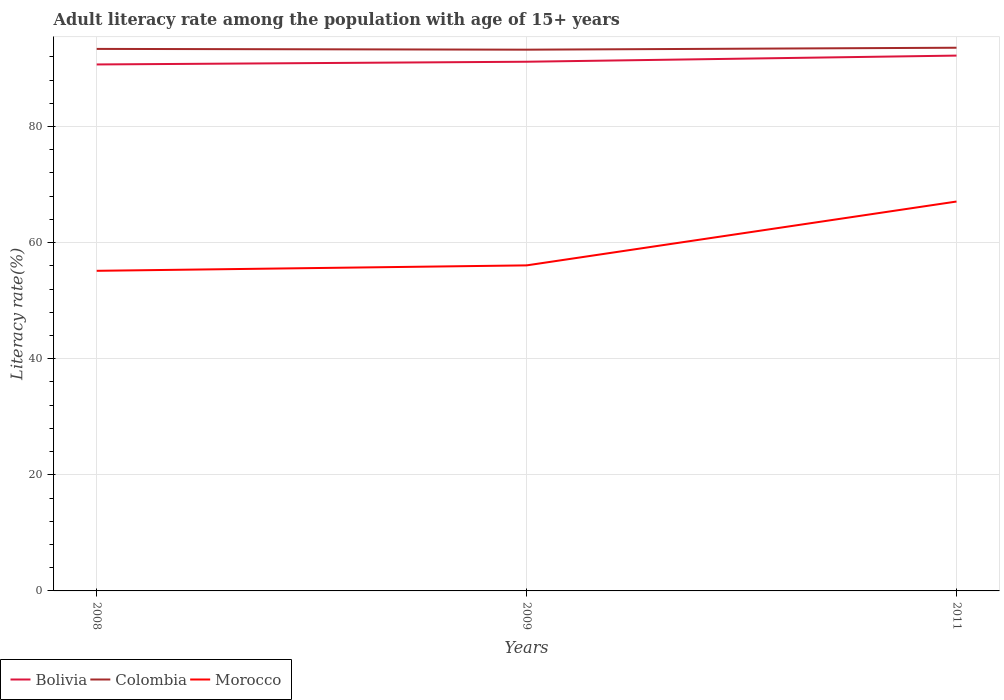Does the line corresponding to Colombia intersect with the line corresponding to Bolivia?
Your answer should be very brief. No. Across all years, what is the maximum adult literacy rate in Colombia?
Your answer should be very brief. 93.24. What is the total adult literacy rate in Colombia in the graph?
Offer a very short reply. -0.2. What is the difference between the highest and the second highest adult literacy rate in Bolivia?
Provide a succinct answer. 1.53. Is the adult literacy rate in Bolivia strictly greater than the adult literacy rate in Morocco over the years?
Your response must be concise. No. How many lines are there?
Provide a succinct answer. 3. How many years are there in the graph?
Keep it short and to the point. 3. Does the graph contain any zero values?
Keep it short and to the point. No. Does the graph contain grids?
Provide a succinct answer. Yes. How many legend labels are there?
Your answer should be very brief. 3. What is the title of the graph?
Provide a short and direct response. Adult literacy rate among the population with age of 15+ years. What is the label or title of the X-axis?
Provide a succinct answer. Years. What is the label or title of the Y-axis?
Ensure brevity in your answer.  Literacy rate(%). What is the Literacy rate(%) of Bolivia in 2008?
Provide a short and direct response. 90.7. What is the Literacy rate(%) of Colombia in 2008?
Make the answer very short. 93.38. What is the Literacy rate(%) in Morocco in 2008?
Offer a terse response. 55.15. What is the Literacy rate(%) of Bolivia in 2009?
Your answer should be very brief. 91.17. What is the Literacy rate(%) of Colombia in 2009?
Offer a terse response. 93.24. What is the Literacy rate(%) of Morocco in 2009?
Offer a terse response. 56.08. What is the Literacy rate(%) in Bolivia in 2011?
Give a very brief answer. 92.23. What is the Literacy rate(%) in Colombia in 2011?
Ensure brevity in your answer.  93.58. What is the Literacy rate(%) of Morocco in 2011?
Your response must be concise. 67.08. Across all years, what is the maximum Literacy rate(%) in Bolivia?
Make the answer very short. 92.23. Across all years, what is the maximum Literacy rate(%) in Colombia?
Provide a short and direct response. 93.58. Across all years, what is the maximum Literacy rate(%) of Morocco?
Make the answer very short. 67.08. Across all years, what is the minimum Literacy rate(%) of Bolivia?
Provide a short and direct response. 90.7. Across all years, what is the minimum Literacy rate(%) of Colombia?
Give a very brief answer. 93.24. Across all years, what is the minimum Literacy rate(%) in Morocco?
Provide a short and direct response. 55.15. What is the total Literacy rate(%) in Bolivia in the graph?
Your answer should be compact. 274.09. What is the total Literacy rate(%) in Colombia in the graph?
Keep it short and to the point. 280.2. What is the total Literacy rate(%) of Morocco in the graph?
Give a very brief answer. 178.32. What is the difference between the Literacy rate(%) of Bolivia in 2008 and that in 2009?
Give a very brief answer. -0.47. What is the difference between the Literacy rate(%) of Colombia in 2008 and that in 2009?
Your response must be concise. 0.13. What is the difference between the Literacy rate(%) of Morocco in 2008 and that in 2009?
Your answer should be compact. -0.94. What is the difference between the Literacy rate(%) in Bolivia in 2008 and that in 2011?
Provide a succinct answer. -1.53. What is the difference between the Literacy rate(%) of Colombia in 2008 and that in 2011?
Give a very brief answer. -0.2. What is the difference between the Literacy rate(%) in Morocco in 2008 and that in 2011?
Provide a short and direct response. -11.94. What is the difference between the Literacy rate(%) of Bolivia in 2009 and that in 2011?
Give a very brief answer. -1.06. What is the difference between the Literacy rate(%) in Colombia in 2009 and that in 2011?
Offer a terse response. -0.34. What is the difference between the Literacy rate(%) of Morocco in 2009 and that in 2011?
Your answer should be compact. -11. What is the difference between the Literacy rate(%) of Bolivia in 2008 and the Literacy rate(%) of Colombia in 2009?
Make the answer very short. -2.55. What is the difference between the Literacy rate(%) in Bolivia in 2008 and the Literacy rate(%) in Morocco in 2009?
Make the answer very short. 34.61. What is the difference between the Literacy rate(%) of Colombia in 2008 and the Literacy rate(%) of Morocco in 2009?
Your answer should be compact. 37.29. What is the difference between the Literacy rate(%) in Bolivia in 2008 and the Literacy rate(%) in Colombia in 2011?
Provide a short and direct response. -2.88. What is the difference between the Literacy rate(%) of Bolivia in 2008 and the Literacy rate(%) of Morocco in 2011?
Give a very brief answer. 23.61. What is the difference between the Literacy rate(%) in Colombia in 2008 and the Literacy rate(%) in Morocco in 2011?
Your response must be concise. 26.29. What is the difference between the Literacy rate(%) in Bolivia in 2009 and the Literacy rate(%) in Colombia in 2011?
Ensure brevity in your answer.  -2.41. What is the difference between the Literacy rate(%) in Bolivia in 2009 and the Literacy rate(%) in Morocco in 2011?
Offer a terse response. 24.08. What is the difference between the Literacy rate(%) of Colombia in 2009 and the Literacy rate(%) of Morocco in 2011?
Offer a very short reply. 26.16. What is the average Literacy rate(%) in Bolivia per year?
Ensure brevity in your answer.  91.36. What is the average Literacy rate(%) of Colombia per year?
Your answer should be very brief. 93.4. What is the average Literacy rate(%) of Morocco per year?
Make the answer very short. 59.44. In the year 2008, what is the difference between the Literacy rate(%) in Bolivia and Literacy rate(%) in Colombia?
Keep it short and to the point. -2.68. In the year 2008, what is the difference between the Literacy rate(%) of Bolivia and Literacy rate(%) of Morocco?
Make the answer very short. 35.55. In the year 2008, what is the difference between the Literacy rate(%) of Colombia and Literacy rate(%) of Morocco?
Make the answer very short. 38.23. In the year 2009, what is the difference between the Literacy rate(%) of Bolivia and Literacy rate(%) of Colombia?
Keep it short and to the point. -2.08. In the year 2009, what is the difference between the Literacy rate(%) in Bolivia and Literacy rate(%) in Morocco?
Offer a terse response. 35.08. In the year 2009, what is the difference between the Literacy rate(%) in Colombia and Literacy rate(%) in Morocco?
Provide a succinct answer. 37.16. In the year 2011, what is the difference between the Literacy rate(%) of Bolivia and Literacy rate(%) of Colombia?
Offer a terse response. -1.35. In the year 2011, what is the difference between the Literacy rate(%) in Bolivia and Literacy rate(%) in Morocco?
Make the answer very short. 25.14. In the year 2011, what is the difference between the Literacy rate(%) in Colombia and Literacy rate(%) in Morocco?
Ensure brevity in your answer.  26.5. What is the ratio of the Literacy rate(%) of Morocco in 2008 to that in 2009?
Keep it short and to the point. 0.98. What is the ratio of the Literacy rate(%) of Bolivia in 2008 to that in 2011?
Provide a short and direct response. 0.98. What is the ratio of the Literacy rate(%) of Colombia in 2008 to that in 2011?
Keep it short and to the point. 1. What is the ratio of the Literacy rate(%) of Morocco in 2008 to that in 2011?
Your answer should be compact. 0.82. What is the ratio of the Literacy rate(%) of Bolivia in 2009 to that in 2011?
Your answer should be compact. 0.99. What is the ratio of the Literacy rate(%) of Morocco in 2009 to that in 2011?
Your answer should be compact. 0.84. What is the difference between the highest and the second highest Literacy rate(%) in Bolivia?
Offer a terse response. 1.06. What is the difference between the highest and the second highest Literacy rate(%) in Colombia?
Offer a very short reply. 0.2. What is the difference between the highest and the second highest Literacy rate(%) of Morocco?
Your answer should be compact. 11. What is the difference between the highest and the lowest Literacy rate(%) in Bolivia?
Give a very brief answer. 1.53. What is the difference between the highest and the lowest Literacy rate(%) in Colombia?
Keep it short and to the point. 0.34. What is the difference between the highest and the lowest Literacy rate(%) of Morocco?
Your answer should be compact. 11.94. 